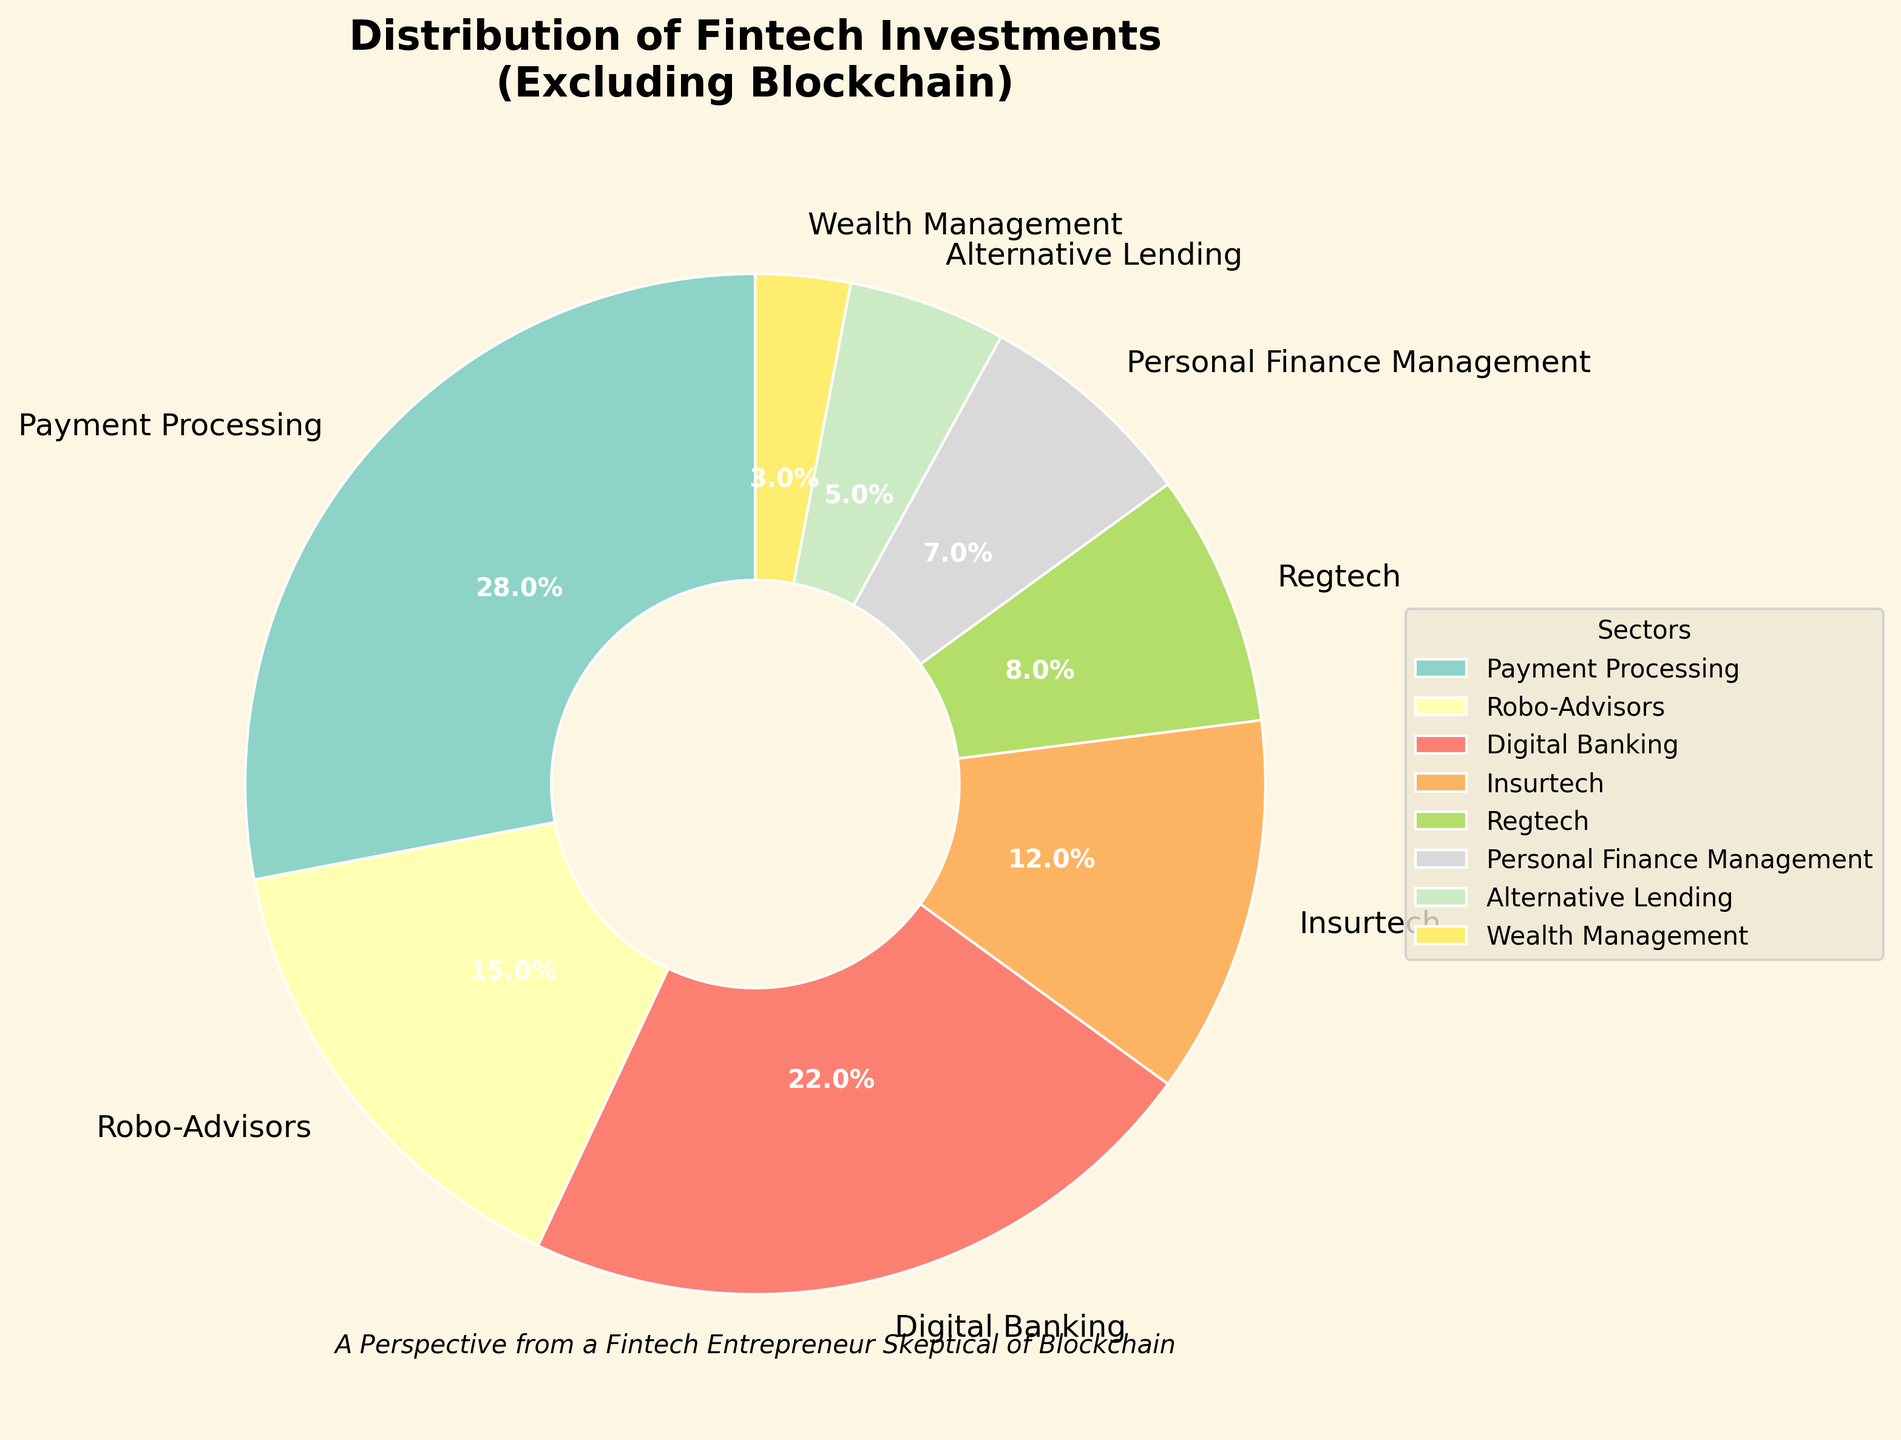Which sector receives the highest percentage of fintech investments? The figure shows different sectors with their investment percentages. The sector with the largest slice of the pie chart represents the highest percentage. Payment Processing has the largest slice.
Answer: Payment Processing How much more investment does Digital Banking receive compared to Wealth Management? Digital Banking receives 22% and Wealth Management receives 3%. The difference is 22% - 3% = 19%.
Answer: 19% Which two sectors combined make up approximately one third of the total investment? One third of 100% is approximately 33%. By adding the percentages, Payment Processing (28%) and Robo-Advisors (15%) together exceed 33% (43%). Instead, adding Insurtech (12%) and Regtech (8%) gives 20%, which with Personal Finance Management (7%) total 27%. Better pairs do not exist, making Insurtech, Regtech, and Personal Finance Management combined meet one third closely.
Answer: Insurtech, Regtech, Personal Finance Management Does Alternative Lending receive more or less investment than Insurtech? The sectors' percentages are clearly labeled in the pie chart. Alternative Lending receives 5%, which is less than Insurtech's 12%.
Answer: Less Which sector has the smallest investment percentage? The pie chart shows the slices labeled with percentages, and the smallest number corresponds to the smallest slice. Wealth Management has the smallest at 3%.
Answer: Wealth Management What is the total combined percentage for the top three sectors? The top three sectors by percentage are Payment Processing (28%), Digital Banking (22%), and Robo-Advisors (15%). Summing these percentages gives 28% + 22% + 15% = 65%.
Answer: 65% Compare the investment percentages of Regtech and Personal Finance Management. Which one receives a higher percentage? Regtech receives 8% and Personal Finance Management receives 7%. Comparing these values, Regtech receives a higher percentage.
Answer: Regtech Which sector that sits at 22% and what is its slice color? Examining the pie chart, Digital Banking sits at 22%, and looking at the segment colored distinctly in line with the visual setting, it appears as a specific color from the Set3 palette. Assume the corresponding slice appears in a bright hue often seen visually vivid among multiple bright colors.
Answer: Digital Banking, bright color Is the total investment in Alternative Lending and Wealth Management higher or lower than Insurtech? Alternative Lending is 5% and Wealth Management is 3%, totaling 5% + 3% = 8%. Insurtech is 12%. Comparing these values, 8% is less than 12%.
Answer: Lower 